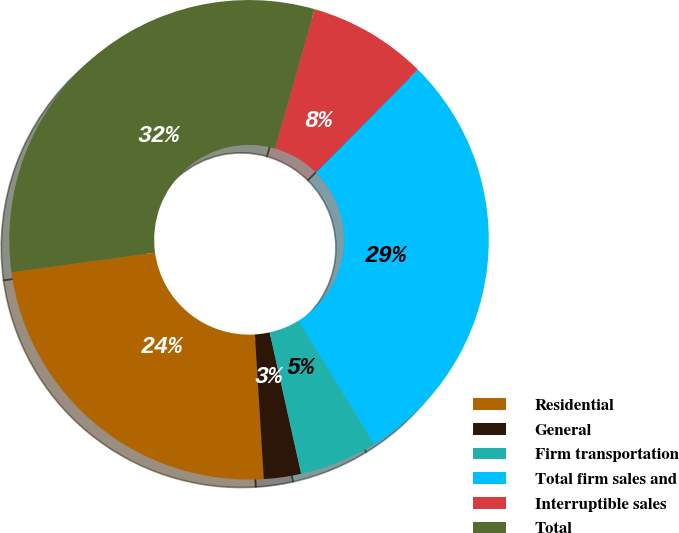Convert chart. <chart><loc_0><loc_0><loc_500><loc_500><pie_chart><fcel>Residential<fcel>General<fcel>Firm transportation<fcel>Total firm sales and<fcel>Interruptible sales<fcel>Total<nl><fcel>23.81%<fcel>2.51%<fcel>5.26%<fcel>28.82%<fcel>8.02%<fcel>31.58%<nl></chart> 